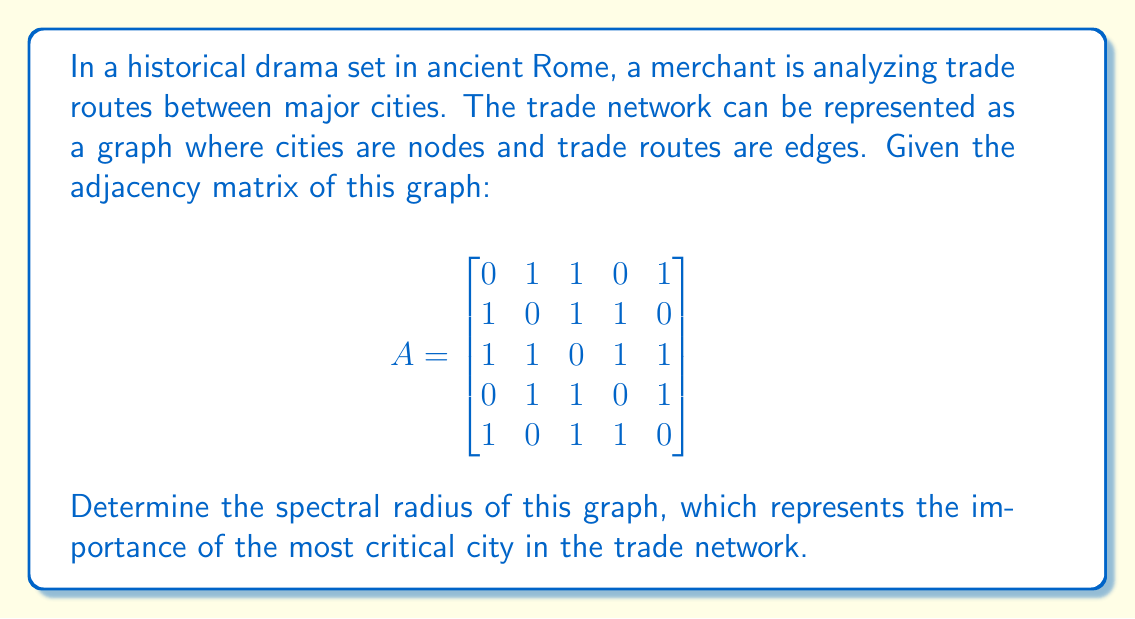Could you help me with this problem? To find the spectral radius of the graph, we need to follow these steps:

1) The spectral radius is the largest absolute value of the eigenvalues of the adjacency matrix A.

2) To find the eigenvalues, we need to solve the characteristic equation:
   $\det(A - \lambda I) = 0$

3) Expanding this determinant:
   $$\begin{vmatrix}
   -\lambda & 1 & 1 & 0 & 1\\
   1 & -\lambda & 1 & 1 & 0\\
   1 & 1 & -\lambda & 1 & 1\\
   0 & 1 & 1 & -\lambda & 1\\
   1 & 0 & 1 & 1 & -\lambda
   \end{vmatrix} = 0$$

4) This leads to the characteristic polynomial:
   $\lambda^5 - 10\lambda^3 - 5\lambda^2 + 4\lambda + 1 = 0$

5) Solving this equation numerically (as it's a 5th-degree polynomial), we get the eigenvalues:
   $\lambda_1 \approx 2.6180$
   $\lambda_2 \approx -1.6180$
   $\lambda_3 \approx 1.0000$
   $\lambda_4 \approx -1.0000$
   $\lambda_5 \approx 0$

6) The spectral radius is the largest absolute value among these eigenvalues, which is approximately 2.6180.

Interestingly, this value is very close to the golden ratio, $\phi = \frac{1+\sqrt{5}}{2} \approx 1.6180$. In fact, the exact value of the spectral radius is $\phi + 1 = \frac{3+\sqrt{5}}{2}$.
Answer: $\frac{3+\sqrt{5}}{2}$ 